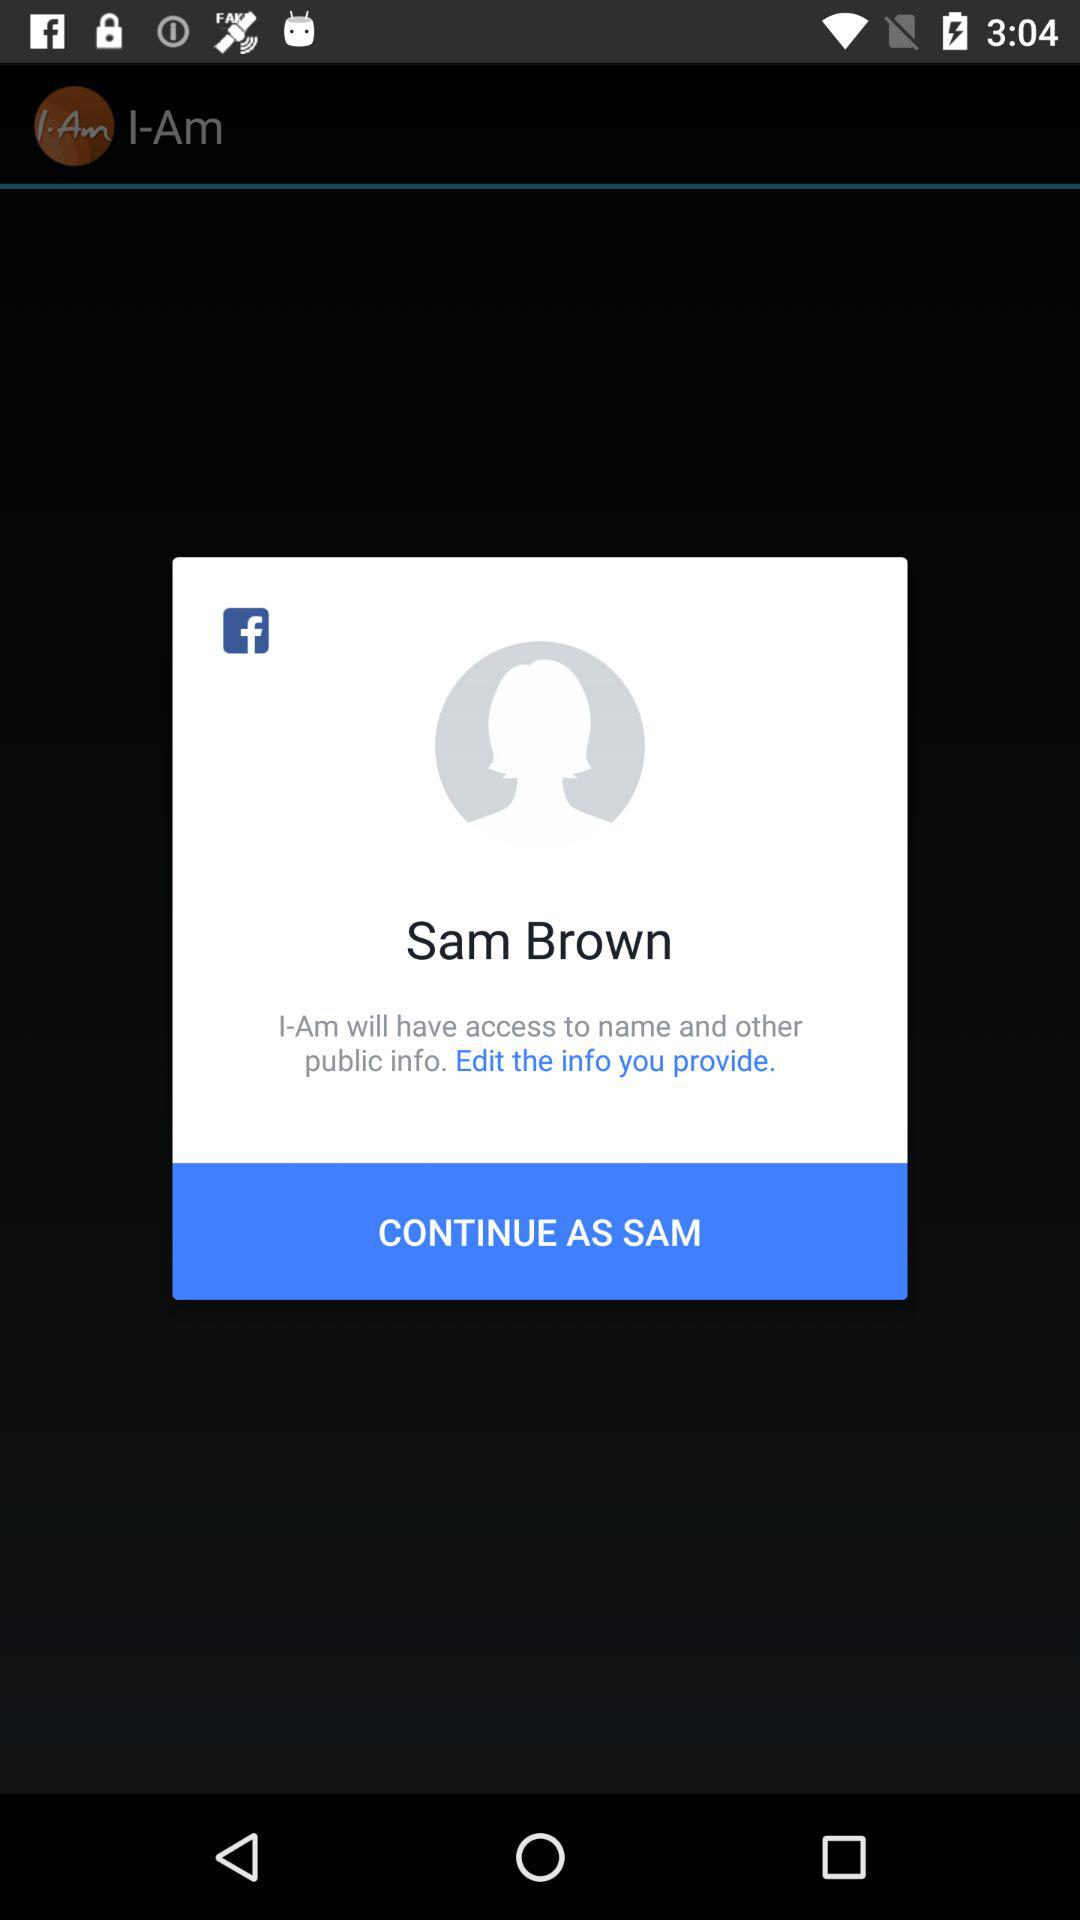Which info can be edited to be provided?
When the provided information is insufficient, respond with <no answer>. <no answer> 